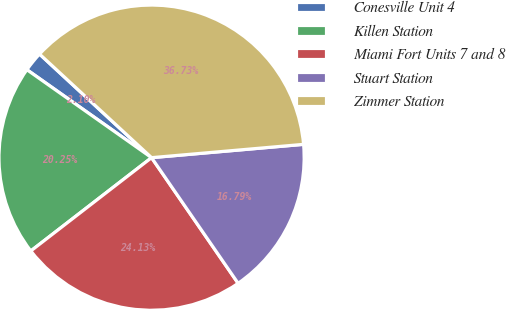Convert chart to OTSL. <chart><loc_0><loc_0><loc_500><loc_500><pie_chart><fcel>Conesville Unit 4<fcel>Killen Station<fcel>Miami Fort Units 7 and 8<fcel>Stuart Station<fcel>Zimmer Station<nl><fcel>2.1%<fcel>20.25%<fcel>24.13%<fcel>16.79%<fcel>36.73%<nl></chart> 